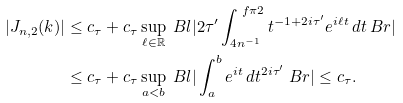Convert formula to latex. <formula><loc_0><loc_0><loc_500><loc_500>| J _ { n , 2 } ( k ) | & \leq c _ { \tau } + c _ { \tau } \sup _ { \ell \in \mathbb { R } } \ B l | 2 \tau ^ { \prime } \int _ { 4 n ^ { - 1 } } ^ { \ f \pi 2 } t ^ { - 1 + 2 i \tau ^ { \prime } } e ^ { i \ell t } \, d t \ B r | \\ & \leq c _ { \tau } + c _ { \tau } \sup _ { a < b } \ B l | \int _ { a } ^ { b } e ^ { i t } \, d t ^ { 2 i \tau ^ { \prime } } \ B r | \leq c _ { \tau } .</formula> 